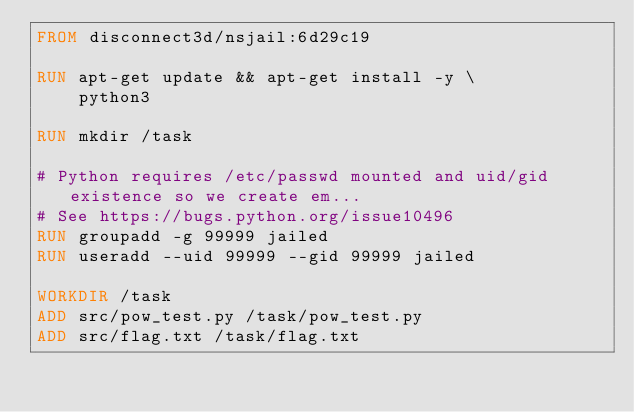<code> <loc_0><loc_0><loc_500><loc_500><_Dockerfile_>FROM disconnect3d/nsjail:6d29c19

RUN apt-get update && apt-get install -y \
    python3

RUN mkdir /task

# Python requires /etc/passwd mounted and uid/gid existence so we create em...
# See https://bugs.python.org/issue10496
RUN groupadd -g 99999 jailed
RUN useradd --uid 99999 --gid 99999 jailed

WORKDIR /task
ADD src/pow_test.py /task/pow_test.py
ADD src/flag.txt /task/flag.txt

</code> 